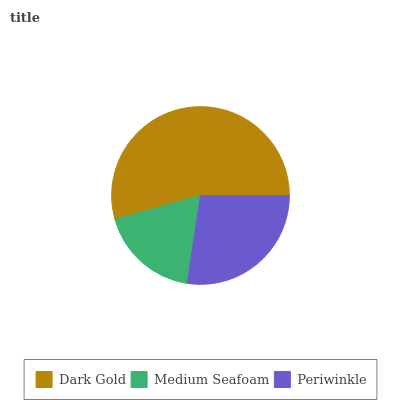Is Medium Seafoam the minimum?
Answer yes or no. Yes. Is Dark Gold the maximum?
Answer yes or no. Yes. Is Periwinkle the minimum?
Answer yes or no. No. Is Periwinkle the maximum?
Answer yes or no. No. Is Periwinkle greater than Medium Seafoam?
Answer yes or no. Yes. Is Medium Seafoam less than Periwinkle?
Answer yes or no. Yes. Is Medium Seafoam greater than Periwinkle?
Answer yes or no. No. Is Periwinkle less than Medium Seafoam?
Answer yes or no. No. Is Periwinkle the high median?
Answer yes or no. Yes. Is Periwinkle the low median?
Answer yes or no. Yes. Is Dark Gold the high median?
Answer yes or no. No. Is Medium Seafoam the low median?
Answer yes or no. No. 